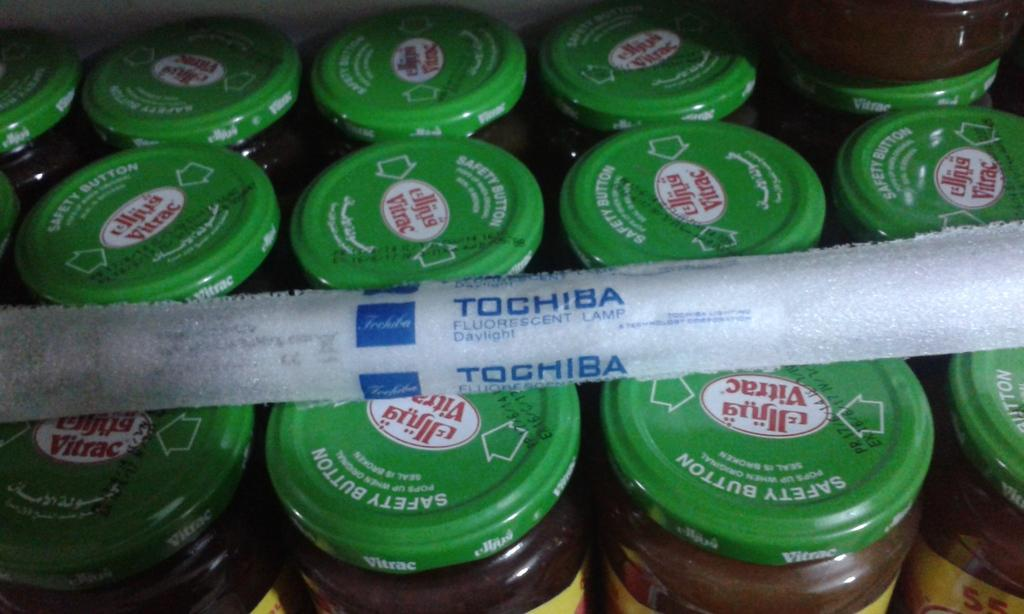<image>
Write a terse but informative summary of the picture. the tochiba sits on top of the jars with green tops 